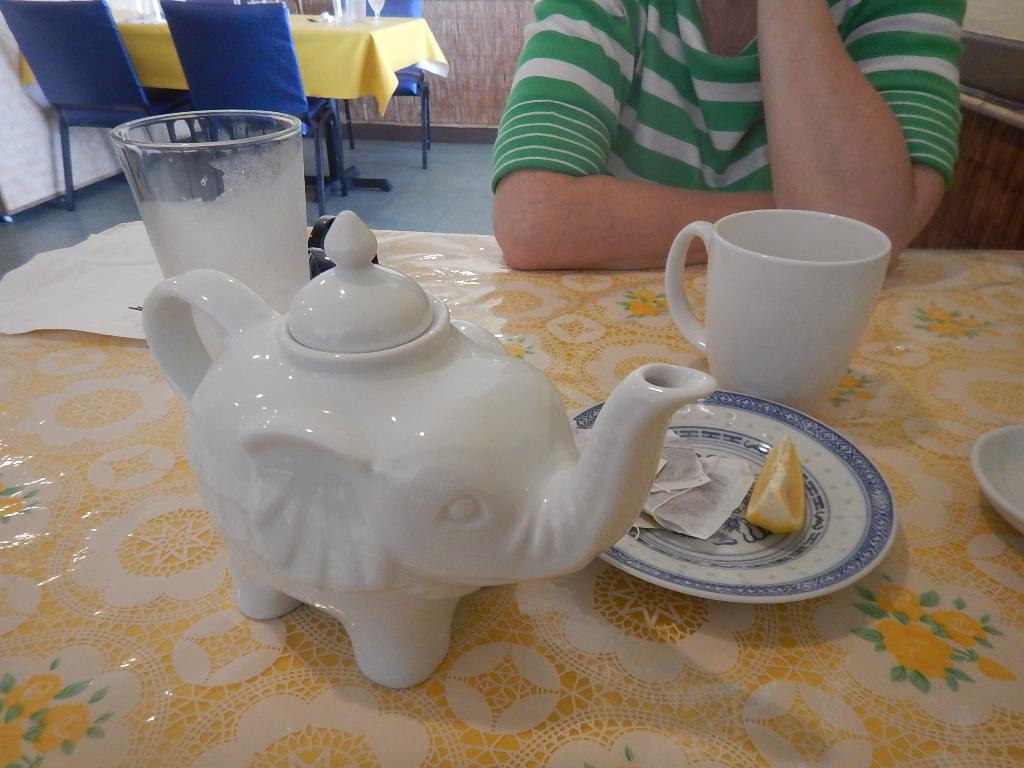What is the person in the image doing? The person is sitting on a chair in the image. What items are in front of the person? There is a tea cup, a glass, and a plate in front of the person. What is on the plate? There is an orange slice on the plate. What is the significance of the birth date on the plate in the image? There is no birth date present on the plate in the image; it features an orange slice. 